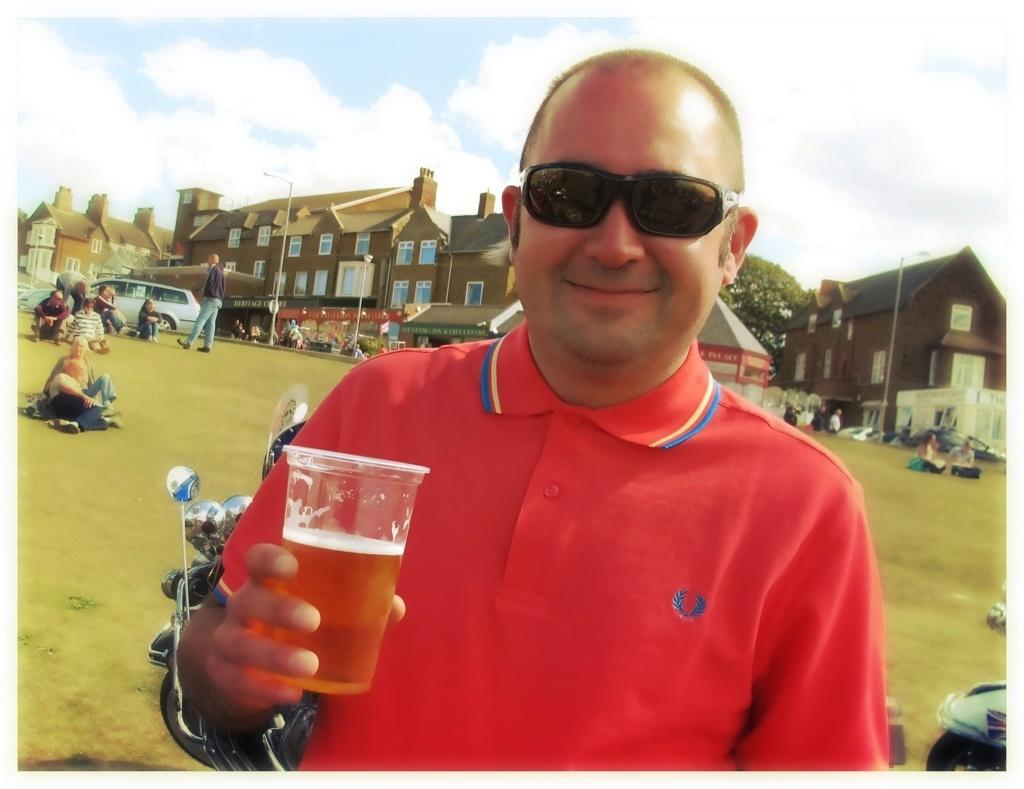What is the main subject of the image? There is a man in the image. What is the man doing in the image? The man is standing and smiling in the image. What is the man holding in his hand? The man is holding a glass in his hand. What can be seen in the background of the image? There are buildings, other people, a car, a pole, the sky, clouds, and trees in the background of the image. What scientific discovery was made by the man in the image? There is no indication in the image that the man made any scientific discovery. 